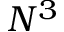<formula> <loc_0><loc_0><loc_500><loc_500>N ^ { 3 }</formula> 